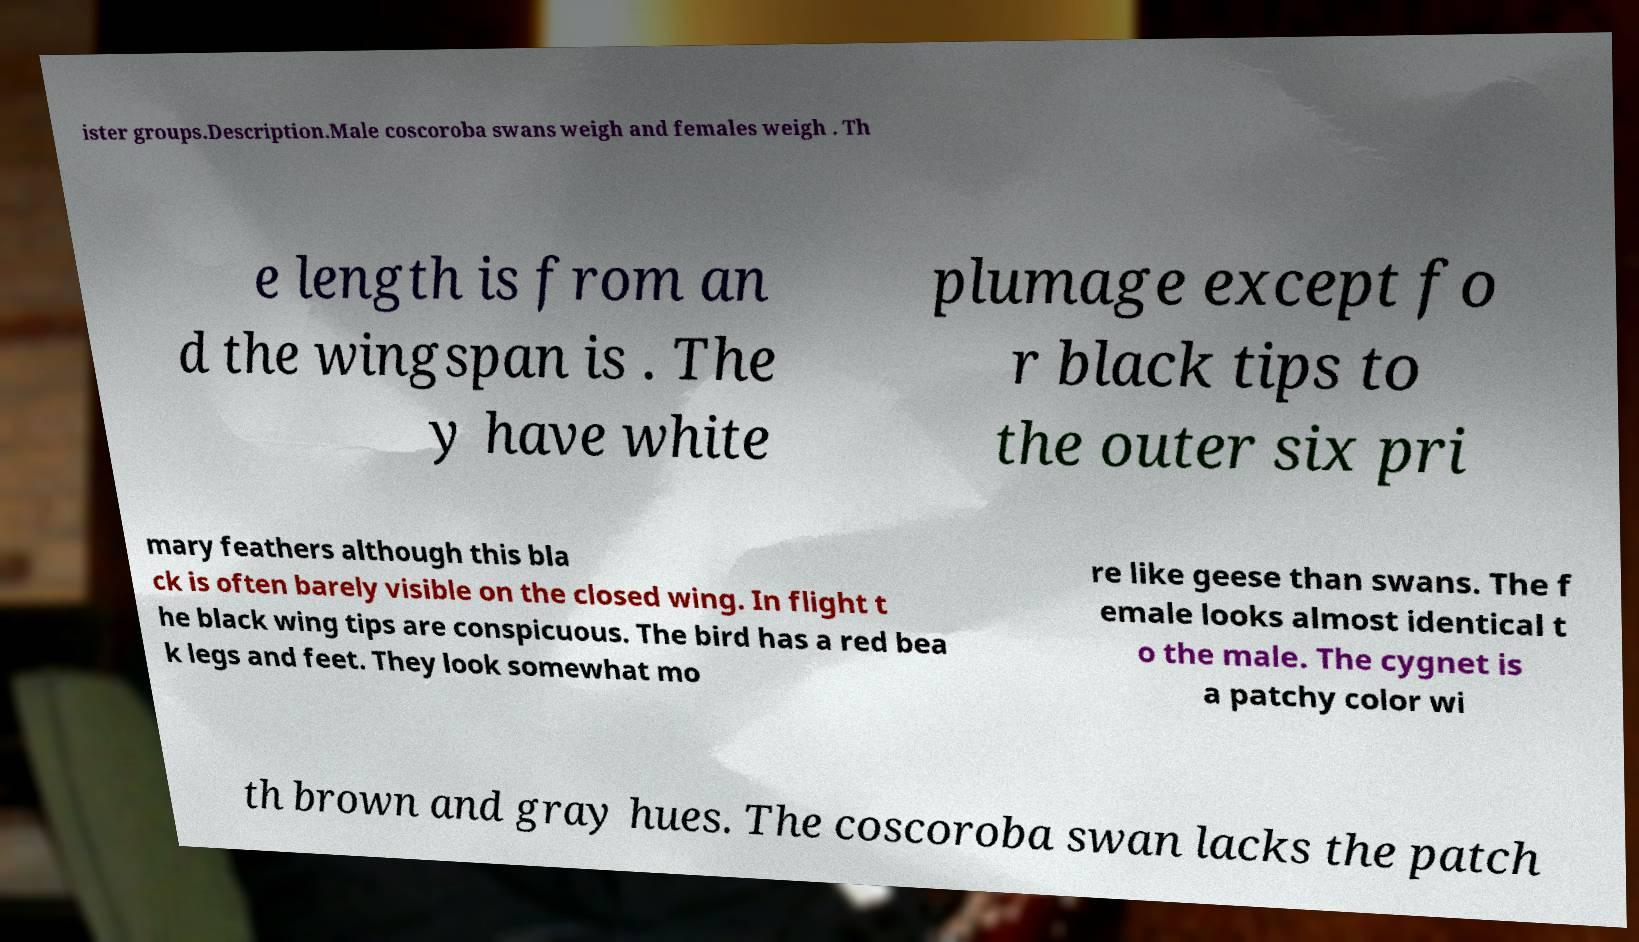Could you assist in decoding the text presented in this image and type it out clearly? ister groups.Description.Male coscoroba swans weigh and females weigh . Th e length is from an d the wingspan is . The y have white plumage except fo r black tips to the outer six pri mary feathers although this bla ck is often barely visible on the closed wing. In flight t he black wing tips are conspicuous. The bird has a red bea k legs and feet. They look somewhat mo re like geese than swans. The f emale looks almost identical t o the male. The cygnet is a patchy color wi th brown and gray hues. The coscoroba swan lacks the patch 